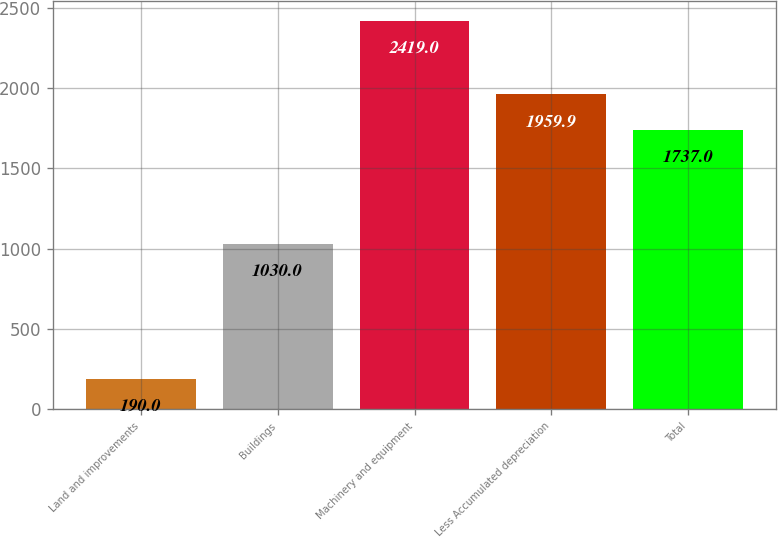Convert chart. <chart><loc_0><loc_0><loc_500><loc_500><bar_chart><fcel>Land and improvements<fcel>Buildings<fcel>Machinery and equipment<fcel>Less Accumulated depreciation<fcel>Total<nl><fcel>190<fcel>1030<fcel>2419<fcel>1959.9<fcel>1737<nl></chart> 